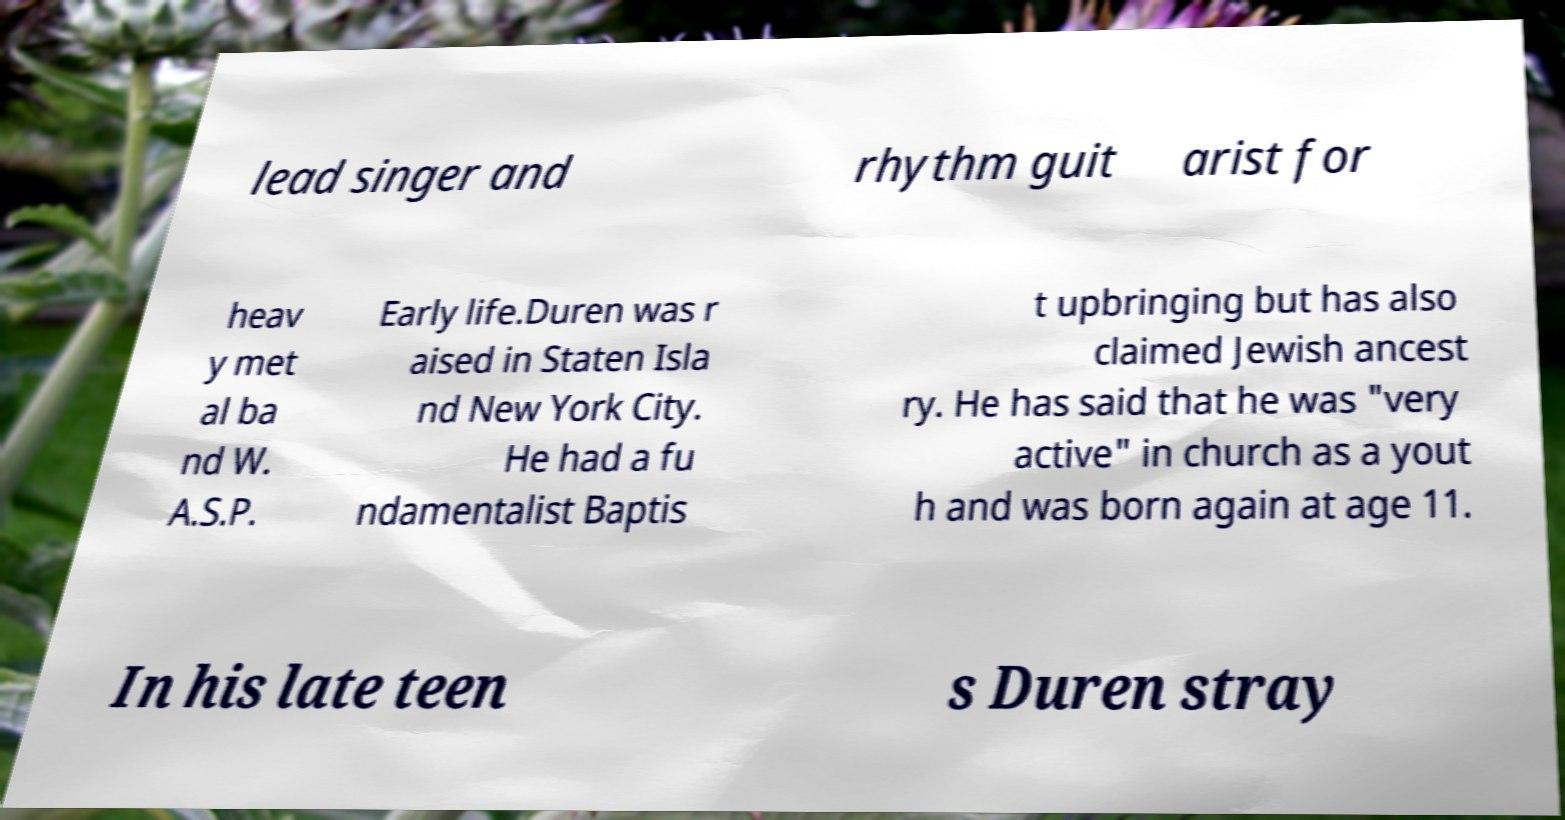Can you accurately transcribe the text from the provided image for me? lead singer and rhythm guit arist for heav y met al ba nd W. A.S.P. Early life.Duren was r aised in Staten Isla nd New York City. He had a fu ndamentalist Baptis t upbringing but has also claimed Jewish ancest ry. He has said that he was "very active" in church as a yout h and was born again at age 11. In his late teen s Duren stray 